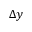Convert formula to latex. <formula><loc_0><loc_0><loc_500><loc_500>\Delta y</formula> 